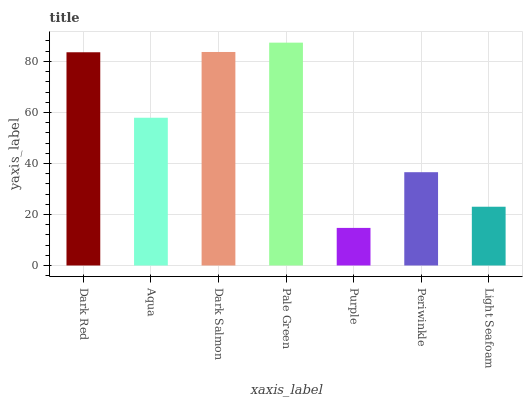Is Purple the minimum?
Answer yes or no. Yes. Is Pale Green the maximum?
Answer yes or no. Yes. Is Aqua the minimum?
Answer yes or no. No. Is Aqua the maximum?
Answer yes or no. No. Is Dark Red greater than Aqua?
Answer yes or no. Yes. Is Aqua less than Dark Red?
Answer yes or no. Yes. Is Aqua greater than Dark Red?
Answer yes or no. No. Is Dark Red less than Aqua?
Answer yes or no. No. Is Aqua the high median?
Answer yes or no. Yes. Is Aqua the low median?
Answer yes or no. Yes. Is Pale Green the high median?
Answer yes or no. No. Is Periwinkle the low median?
Answer yes or no. No. 